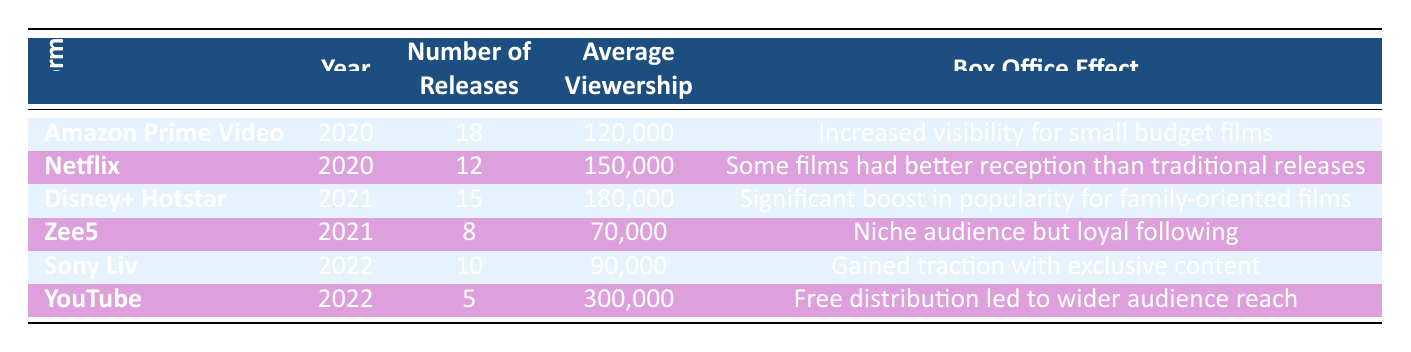What was the average viewership for Malayalam films released on Netflix in 2020? The table shows that Netflix had an average viewership of 150,000 for the films released in 2020.
Answer: 150,000 How many releases did Amazon Prime Video have in 2020? According to the table, Amazon Prime Video had 18 releases in the year 2020.
Answer: 18 Which platform had the most number of releases in 2021? In 2021, the platform with the most number of releases is Disney+ Hotstar with 15 releases, which is greater than the 8 releases on Zee5.
Answer: Disney+ Hotstar What was the box office effect of YouTube for the Malayalam films released in 2022? The table states that the box office effect of YouTube in 2022 was "Free distribution led to wider audience reach."
Answer: Free distribution led to wider audience reach What is the average viewership of films across all platforms in 2021? To find the average viewership for 2021, we take the average of Disney+ Hotstar (180,000) and Zee5 (70,000), resulting in a total of 250,000. Dividing this by 2 gives us 125,000 as the average viewership for that year.
Answer: 125,000 Did Sony Liv release more films in 2022 than Netflix did in 2020? Sony Liv had 10 releases in 2022 whereas Netflix had 12 releases in 2020. Therefore, the statement is false as Netflix had more releases.
Answer: No How many total releases were there on streaming platforms combined in 2020? Adding the number of releases from Amazon Prime Video (18) and Netflix (12) for 2020 gives a total of 30 releases.
Answer: 30 Which streaming platform showed a significant boost in popularity for family-oriented films in 2021? The data points show that Disney+ Hotstar had a significant boost in popularity for family-oriented films according to its box office effect description for that year.
Answer: Disney+ Hotstar Which platform had the lowest average viewership in 2021? Reviewing the average viewership for both platforms in 2021, Zee5 had the lowest at 70,000 compared to Disney+ Hotstar's 180,000.
Answer: Zee5 